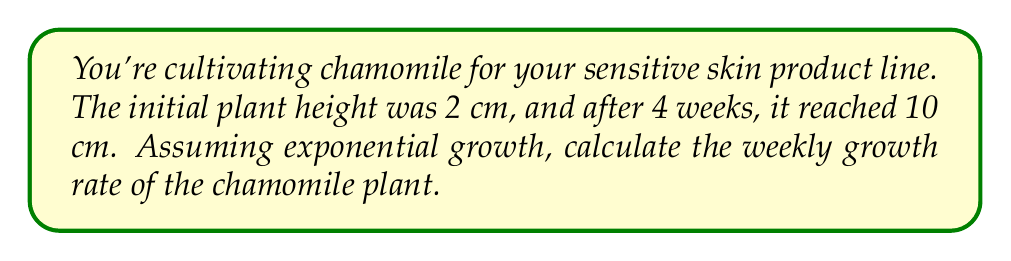Provide a solution to this math problem. Let's approach this step-by-step:

1) The exponential growth formula is:
   $$A = P(1 + r)^t$$
   Where:
   $A$ = Final amount
   $P$ = Initial amount
   $r$ = Growth rate (per time period)
   $t$ = Number of time periods

2) We know:
   $P = 2$ cm (initial height)
   $A = 10$ cm (final height)
   $t = 4$ weeks

3) Let's plug these into our formula:
   $$10 = 2(1 + r)^4$$

4) Divide both sides by 2:
   $$5 = (1 + r)^4$$

5) Take the fourth root of both sides:
   $$\sqrt[4]{5} = 1 + r$$

6) Subtract 1 from both sides:
   $$\sqrt[4]{5} - 1 = r$$

7) Calculate the value:
   $$r \approx 1.4953 - 1 = 0.4953$$

8) Convert to percentage:
   $$0.4953 \times 100\% \approx 49.53\%$$

Therefore, the weekly growth rate is approximately 49.53%.
Answer: 49.53% 